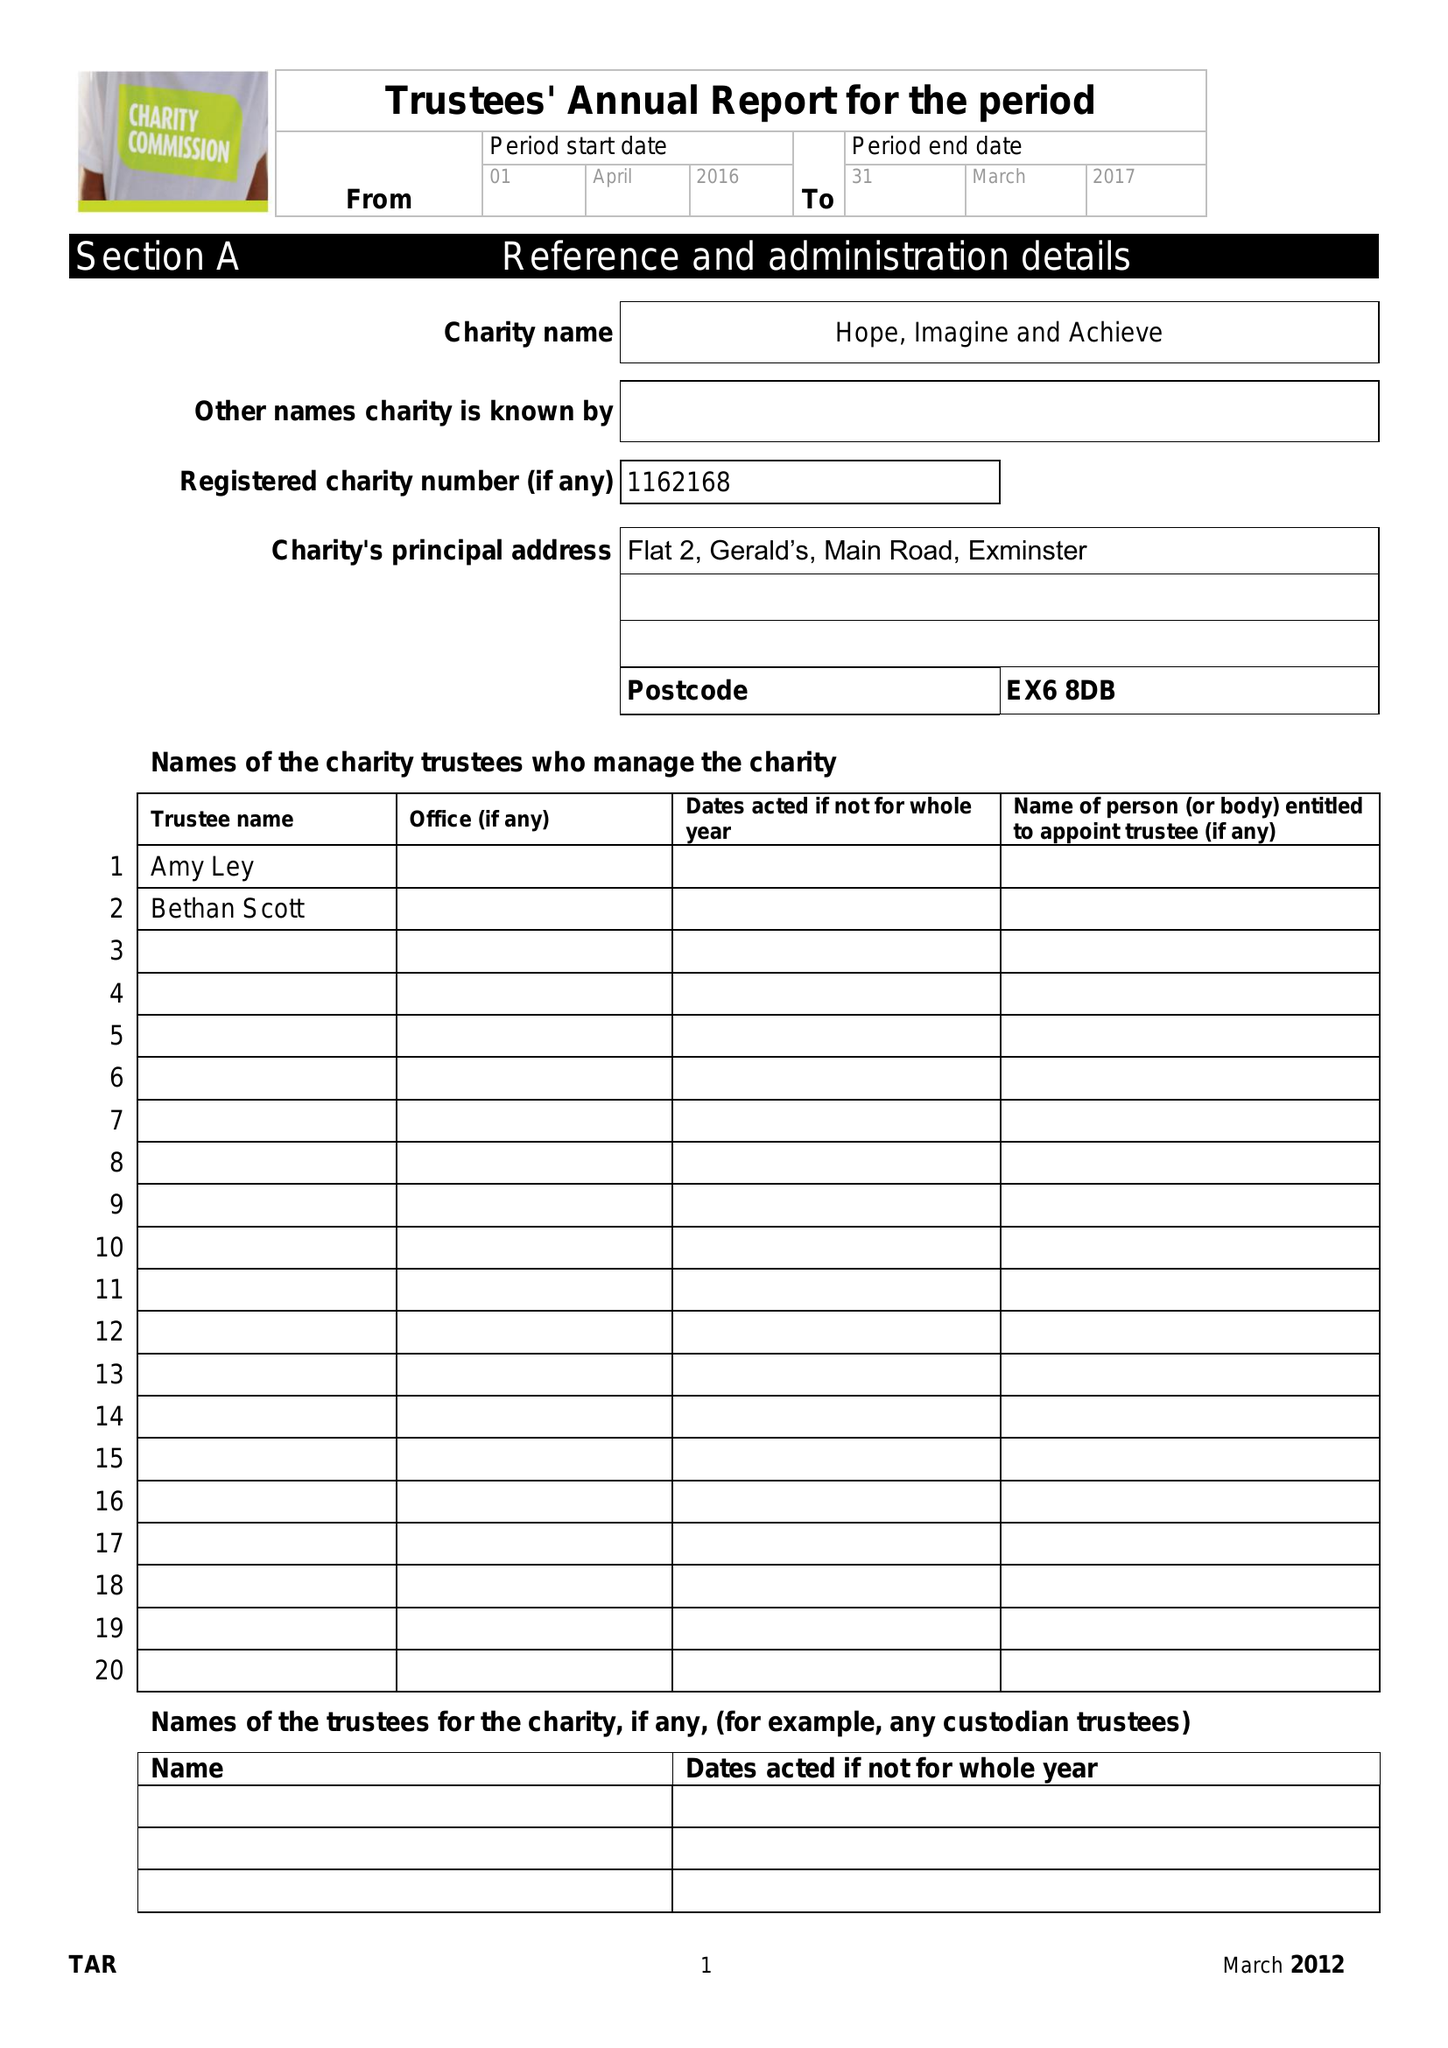What is the value for the report_date?
Answer the question using a single word or phrase. 2017-04-05 